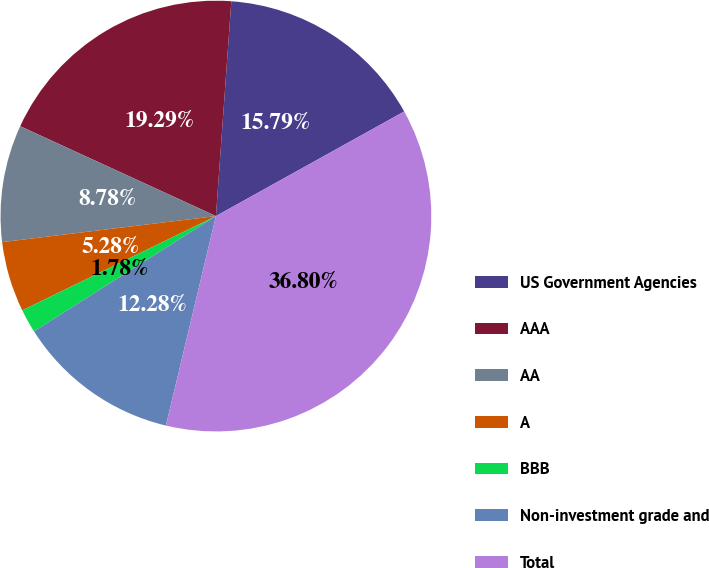<chart> <loc_0><loc_0><loc_500><loc_500><pie_chart><fcel>US Government Agencies<fcel>AAA<fcel>AA<fcel>A<fcel>BBB<fcel>Non-investment grade and<fcel>Total<nl><fcel>15.79%<fcel>19.29%<fcel>8.78%<fcel>5.28%<fcel>1.78%<fcel>12.28%<fcel>36.8%<nl></chart> 